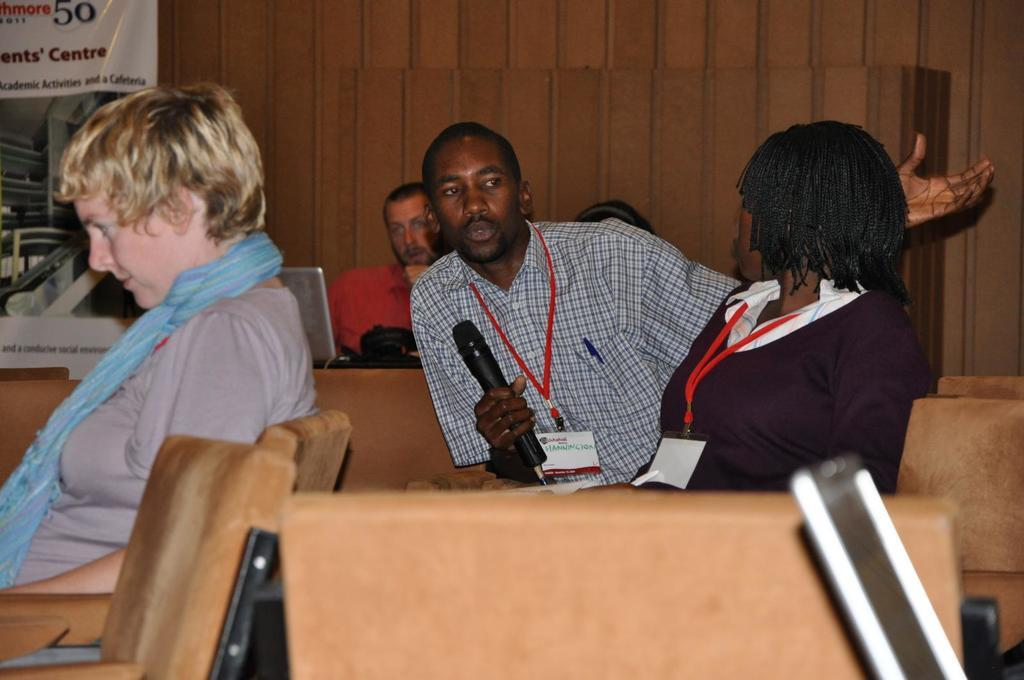How many people are in the image? There is a group of people in the image. What are the people doing in the image? The people are sitting on a chair. Can you describe the woman in the image? The woman is holding a microphone and wearing a badge. What can be seen in the background of the image? There is a banner and a wooden wall in the background. What is the weight of the doll in the image? There is no doll present in the image, so it is not possible to determine its weight. 